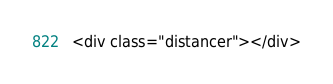<code> <loc_0><loc_0><loc_500><loc_500><_PHP_><div class="distancer"></div></code> 